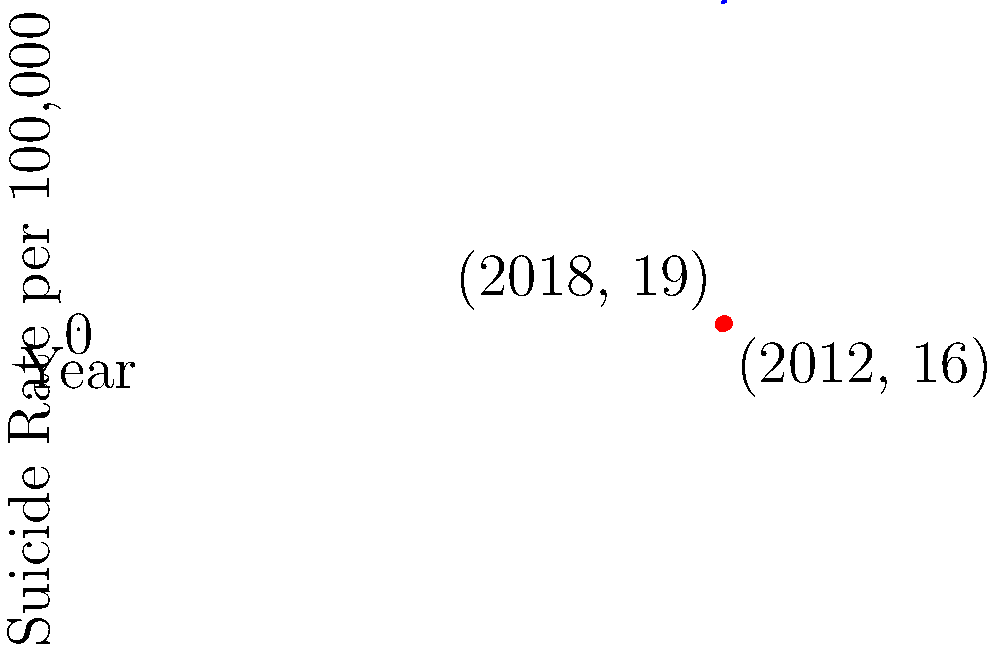A graph shows the suicide rate per 100,000 people for males in a specific region over time. Two data points are highlighted: (2012, 16) and (2018, 19). Calculate the slope of the line connecting these two points. What does this slope represent in the context of male suicide rates? To calculate the slope of the line connecting the two points, we'll use the slope formula:

$$ \text{Slope} = \frac{y_2 - y_1}{x_2 - x_1} $$

Where $(x_1, y_1)$ is the first point (2012, 16) and $(x_2, y_2)$ is the second point (2018, 19).

Step 1: Identify the coordinates
$(x_1, y_1) = (2012, 16)$
$(x_2, y_2) = (2018, 19)$

Step 2: Calculate the change in y (rise)
$y_2 - y_1 = 19 - 16 = 3$

Step 3: Calculate the change in x (run)
$x_2 - x_1 = 2018 - 2012 = 6$

Step 4: Apply the slope formula
$$ \text{Slope} = \frac{3}{6} = 0.5 $$

Interpretation: The slope of 0.5 represents the average annual increase in the suicide rate per 100,000 males in this region between 2012 and 2018. Specifically, it indicates that the suicide rate increased by 0.5 per 100,000 males each year during this period.
Answer: 0.5 suicides per 100,000 males per year 